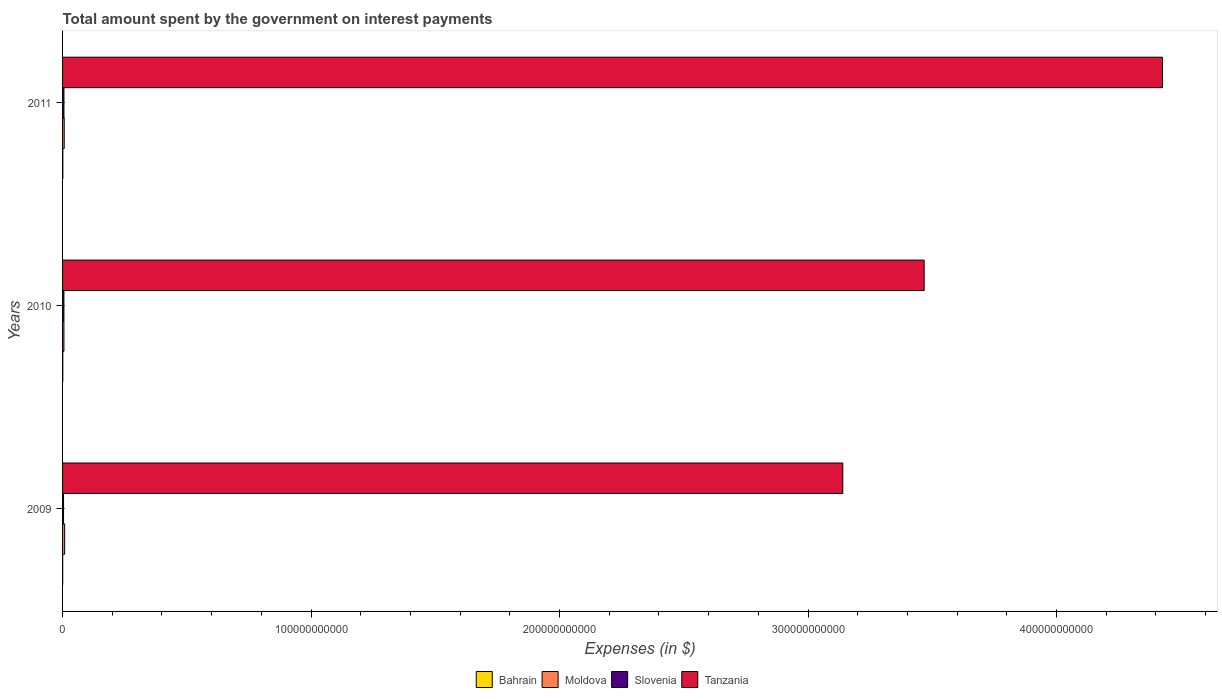How many groups of bars are there?
Your answer should be compact. 3. Are the number of bars on each tick of the Y-axis equal?
Make the answer very short. Yes. How many bars are there on the 3rd tick from the top?
Provide a succinct answer. 4. In how many cases, is the number of bars for a given year not equal to the number of legend labels?
Provide a succinct answer. 0. What is the amount spent on interest payments by the government in Moldova in 2010?
Provide a short and direct response. 5.48e+08. Across all years, what is the maximum amount spent on interest payments by the government in Bahrain?
Provide a short and direct response. 1.15e+08. Across all years, what is the minimum amount spent on interest payments by the government in Bahrain?
Provide a short and direct response. 5.00e+07. In which year was the amount spent on interest payments by the government in Moldova maximum?
Keep it short and to the point. 2009. What is the total amount spent on interest payments by the government in Bahrain in the graph?
Provide a succinct answer. 2.55e+08. What is the difference between the amount spent on interest payments by the government in Tanzania in 2010 and that in 2011?
Offer a terse response. -9.59e+1. What is the difference between the amount spent on interest payments by the government in Moldova in 2010 and the amount spent on interest payments by the government in Slovenia in 2009?
Your response must be concise. 1.52e+08. What is the average amount spent on interest payments by the government in Slovenia per year?
Offer a terse response. 5.00e+08. In the year 2011, what is the difference between the amount spent on interest payments by the government in Tanzania and amount spent on interest payments by the government in Moldova?
Provide a succinct answer. 4.42e+11. What is the ratio of the amount spent on interest payments by the government in Tanzania in 2010 to that in 2011?
Your answer should be compact. 0.78. Is the amount spent on interest payments by the government in Slovenia in 2009 less than that in 2011?
Give a very brief answer. Yes. Is the difference between the amount spent on interest payments by the government in Tanzania in 2010 and 2011 greater than the difference between the amount spent on interest payments by the government in Moldova in 2010 and 2011?
Offer a terse response. No. What is the difference between the highest and the second highest amount spent on interest payments by the government in Bahrain?
Provide a short and direct response. 2.39e+07. What is the difference between the highest and the lowest amount spent on interest payments by the government in Moldova?
Ensure brevity in your answer.  2.87e+08. Is the sum of the amount spent on interest payments by the government in Bahrain in 2009 and 2011 greater than the maximum amount spent on interest payments by the government in Slovenia across all years?
Your response must be concise. No. What does the 4th bar from the top in 2010 represents?
Ensure brevity in your answer.  Bahrain. What does the 4th bar from the bottom in 2009 represents?
Provide a short and direct response. Tanzania. Is it the case that in every year, the sum of the amount spent on interest payments by the government in Tanzania and amount spent on interest payments by the government in Moldova is greater than the amount spent on interest payments by the government in Bahrain?
Your answer should be compact. Yes. Are all the bars in the graph horizontal?
Provide a short and direct response. Yes. How many years are there in the graph?
Provide a succinct answer. 3. What is the difference between two consecutive major ticks on the X-axis?
Provide a short and direct response. 1.00e+11. Does the graph contain any zero values?
Make the answer very short. No. Does the graph contain grids?
Make the answer very short. No. What is the title of the graph?
Your answer should be compact. Total amount spent by the government on interest payments. What is the label or title of the X-axis?
Offer a very short reply. Expenses (in $). What is the label or title of the Y-axis?
Offer a terse response. Years. What is the Expenses (in $) in Bahrain in 2009?
Give a very brief answer. 5.00e+07. What is the Expenses (in $) in Moldova in 2009?
Offer a very short reply. 8.34e+08. What is the Expenses (in $) in Slovenia in 2009?
Your answer should be very brief. 3.96e+08. What is the Expenses (in $) in Tanzania in 2009?
Give a very brief answer. 3.14e+11. What is the Expenses (in $) in Bahrain in 2010?
Your answer should be compact. 9.06e+07. What is the Expenses (in $) of Moldova in 2010?
Make the answer very short. 5.48e+08. What is the Expenses (in $) of Slovenia in 2010?
Make the answer very short. 5.44e+08. What is the Expenses (in $) in Tanzania in 2010?
Your answer should be compact. 3.47e+11. What is the Expenses (in $) of Bahrain in 2011?
Offer a terse response. 1.15e+08. What is the Expenses (in $) in Moldova in 2011?
Your answer should be compact. 6.62e+08. What is the Expenses (in $) in Slovenia in 2011?
Provide a succinct answer. 5.61e+08. What is the Expenses (in $) of Tanzania in 2011?
Offer a terse response. 4.43e+11. Across all years, what is the maximum Expenses (in $) in Bahrain?
Offer a very short reply. 1.15e+08. Across all years, what is the maximum Expenses (in $) of Moldova?
Offer a terse response. 8.34e+08. Across all years, what is the maximum Expenses (in $) of Slovenia?
Your response must be concise. 5.61e+08. Across all years, what is the maximum Expenses (in $) in Tanzania?
Provide a succinct answer. 4.43e+11. Across all years, what is the minimum Expenses (in $) of Bahrain?
Make the answer very short. 5.00e+07. Across all years, what is the minimum Expenses (in $) in Moldova?
Offer a terse response. 5.48e+08. Across all years, what is the minimum Expenses (in $) in Slovenia?
Your answer should be compact. 3.96e+08. Across all years, what is the minimum Expenses (in $) of Tanzania?
Provide a succinct answer. 3.14e+11. What is the total Expenses (in $) of Bahrain in the graph?
Provide a short and direct response. 2.55e+08. What is the total Expenses (in $) in Moldova in the graph?
Provide a succinct answer. 2.04e+09. What is the total Expenses (in $) in Slovenia in the graph?
Provide a succinct answer. 1.50e+09. What is the total Expenses (in $) of Tanzania in the graph?
Provide a succinct answer. 1.10e+12. What is the difference between the Expenses (in $) in Bahrain in 2009 and that in 2010?
Offer a very short reply. -4.05e+07. What is the difference between the Expenses (in $) in Moldova in 2009 and that in 2010?
Ensure brevity in your answer.  2.87e+08. What is the difference between the Expenses (in $) in Slovenia in 2009 and that in 2010?
Keep it short and to the point. -1.49e+08. What is the difference between the Expenses (in $) of Tanzania in 2009 and that in 2010?
Make the answer very short. -3.27e+1. What is the difference between the Expenses (in $) in Bahrain in 2009 and that in 2011?
Your response must be concise. -6.45e+07. What is the difference between the Expenses (in $) in Moldova in 2009 and that in 2011?
Offer a very short reply. 1.72e+08. What is the difference between the Expenses (in $) of Slovenia in 2009 and that in 2011?
Your answer should be compact. -1.65e+08. What is the difference between the Expenses (in $) in Tanzania in 2009 and that in 2011?
Keep it short and to the point. -1.29e+11. What is the difference between the Expenses (in $) in Bahrain in 2010 and that in 2011?
Your answer should be compact. -2.39e+07. What is the difference between the Expenses (in $) of Moldova in 2010 and that in 2011?
Your answer should be compact. -1.15e+08. What is the difference between the Expenses (in $) in Slovenia in 2010 and that in 2011?
Provide a short and direct response. -1.68e+07. What is the difference between the Expenses (in $) of Tanzania in 2010 and that in 2011?
Provide a succinct answer. -9.59e+1. What is the difference between the Expenses (in $) of Bahrain in 2009 and the Expenses (in $) of Moldova in 2010?
Offer a terse response. -4.98e+08. What is the difference between the Expenses (in $) in Bahrain in 2009 and the Expenses (in $) in Slovenia in 2010?
Provide a succinct answer. -4.94e+08. What is the difference between the Expenses (in $) in Bahrain in 2009 and the Expenses (in $) in Tanzania in 2010?
Provide a short and direct response. -3.47e+11. What is the difference between the Expenses (in $) in Moldova in 2009 and the Expenses (in $) in Slovenia in 2010?
Provide a succinct answer. 2.90e+08. What is the difference between the Expenses (in $) of Moldova in 2009 and the Expenses (in $) of Tanzania in 2010?
Keep it short and to the point. -3.46e+11. What is the difference between the Expenses (in $) in Slovenia in 2009 and the Expenses (in $) in Tanzania in 2010?
Offer a very short reply. -3.46e+11. What is the difference between the Expenses (in $) of Bahrain in 2009 and the Expenses (in $) of Moldova in 2011?
Make the answer very short. -6.12e+08. What is the difference between the Expenses (in $) of Bahrain in 2009 and the Expenses (in $) of Slovenia in 2011?
Your answer should be compact. -5.11e+08. What is the difference between the Expenses (in $) of Bahrain in 2009 and the Expenses (in $) of Tanzania in 2011?
Keep it short and to the point. -4.43e+11. What is the difference between the Expenses (in $) in Moldova in 2009 and the Expenses (in $) in Slovenia in 2011?
Your response must be concise. 2.73e+08. What is the difference between the Expenses (in $) of Moldova in 2009 and the Expenses (in $) of Tanzania in 2011?
Your answer should be very brief. -4.42e+11. What is the difference between the Expenses (in $) of Slovenia in 2009 and the Expenses (in $) of Tanzania in 2011?
Your response must be concise. -4.42e+11. What is the difference between the Expenses (in $) in Bahrain in 2010 and the Expenses (in $) in Moldova in 2011?
Your answer should be compact. -5.72e+08. What is the difference between the Expenses (in $) in Bahrain in 2010 and the Expenses (in $) in Slovenia in 2011?
Make the answer very short. -4.70e+08. What is the difference between the Expenses (in $) in Bahrain in 2010 and the Expenses (in $) in Tanzania in 2011?
Provide a short and direct response. -4.43e+11. What is the difference between the Expenses (in $) of Moldova in 2010 and the Expenses (in $) of Slovenia in 2011?
Your answer should be compact. -1.34e+07. What is the difference between the Expenses (in $) of Moldova in 2010 and the Expenses (in $) of Tanzania in 2011?
Make the answer very short. -4.42e+11. What is the difference between the Expenses (in $) of Slovenia in 2010 and the Expenses (in $) of Tanzania in 2011?
Offer a very short reply. -4.42e+11. What is the average Expenses (in $) in Bahrain per year?
Your response must be concise. 8.50e+07. What is the average Expenses (in $) of Moldova per year?
Provide a succinct answer. 6.81e+08. What is the average Expenses (in $) of Slovenia per year?
Provide a succinct answer. 5.00e+08. What is the average Expenses (in $) in Tanzania per year?
Give a very brief answer. 3.68e+11. In the year 2009, what is the difference between the Expenses (in $) in Bahrain and Expenses (in $) in Moldova?
Your answer should be very brief. -7.84e+08. In the year 2009, what is the difference between the Expenses (in $) in Bahrain and Expenses (in $) in Slovenia?
Ensure brevity in your answer.  -3.46e+08. In the year 2009, what is the difference between the Expenses (in $) of Bahrain and Expenses (in $) of Tanzania?
Offer a terse response. -3.14e+11. In the year 2009, what is the difference between the Expenses (in $) in Moldova and Expenses (in $) in Slovenia?
Offer a terse response. 4.38e+08. In the year 2009, what is the difference between the Expenses (in $) in Moldova and Expenses (in $) in Tanzania?
Your answer should be very brief. -3.13e+11. In the year 2009, what is the difference between the Expenses (in $) of Slovenia and Expenses (in $) of Tanzania?
Your answer should be compact. -3.14e+11. In the year 2010, what is the difference between the Expenses (in $) in Bahrain and Expenses (in $) in Moldova?
Offer a terse response. -4.57e+08. In the year 2010, what is the difference between the Expenses (in $) in Bahrain and Expenses (in $) in Slovenia?
Your answer should be compact. -4.54e+08. In the year 2010, what is the difference between the Expenses (in $) of Bahrain and Expenses (in $) of Tanzania?
Provide a short and direct response. -3.47e+11. In the year 2010, what is the difference between the Expenses (in $) of Moldova and Expenses (in $) of Slovenia?
Offer a terse response. 3.36e+06. In the year 2010, what is the difference between the Expenses (in $) of Moldova and Expenses (in $) of Tanzania?
Offer a very short reply. -3.46e+11. In the year 2010, what is the difference between the Expenses (in $) in Slovenia and Expenses (in $) in Tanzania?
Keep it short and to the point. -3.46e+11. In the year 2011, what is the difference between the Expenses (in $) in Bahrain and Expenses (in $) in Moldova?
Your answer should be compact. -5.48e+08. In the year 2011, what is the difference between the Expenses (in $) in Bahrain and Expenses (in $) in Slovenia?
Give a very brief answer. -4.47e+08. In the year 2011, what is the difference between the Expenses (in $) in Bahrain and Expenses (in $) in Tanzania?
Make the answer very short. -4.43e+11. In the year 2011, what is the difference between the Expenses (in $) of Moldova and Expenses (in $) of Slovenia?
Offer a very short reply. 1.01e+08. In the year 2011, what is the difference between the Expenses (in $) of Moldova and Expenses (in $) of Tanzania?
Offer a terse response. -4.42e+11. In the year 2011, what is the difference between the Expenses (in $) in Slovenia and Expenses (in $) in Tanzania?
Make the answer very short. -4.42e+11. What is the ratio of the Expenses (in $) of Bahrain in 2009 to that in 2010?
Ensure brevity in your answer.  0.55. What is the ratio of the Expenses (in $) in Moldova in 2009 to that in 2010?
Your answer should be compact. 1.52. What is the ratio of the Expenses (in $) of Slovenia in 2009 to that in 2010?
Your response must be concise. 0.73. What is the ratio of the Expenses (in $) of Tanzania in 2009 to that in 2010?
Offer a very short reply. 0.91. What is the ratio of the Expenses (in $) in Bahrain in 2009 to that in 2011?
Your response must be concise. 0.44. What is the ratio of the Expenses (in $) of Moldova in 2009 to that in 2011?
Your answer should be very brief. 1.26. What is the ratio of the Expenses (in $) in Slovenia in 2009 to that in 2011?
Make the answer very short. 0.71. What is the ratio of the Expenses (in $) of Tanzania in 2009 to that in 2011?
Offer a terse response. 0.71. What is the ratio of the Expenses (in $) of Bahrain in 2010 to that in 2011?
Ensure brevity in your answer.  0.79. What is the ratio of the Expenses (in $) of Moldova in 2010 to that in 2011?
Offer a very short reply. 0.83. What is the ratio of the Expenses (in $) in Slovenia in 2010 to that in 2011?
Your answer should be very brief. 0.97. What is the ratio of the Expenses (in $) of Tanzania in 2010 to that in 2011?
Provide a succinct answer. 0.78. What is the difference between the highest and the second highest Expenses (in $) in Bahrain?
Your answer should be compact. 2.39e+07. What is the difference between the highest and the second highest Expenses (in $) of Moldova?
Give a very brief answer. 1.72e+08. What is the difference between the highest and the second highest Expenses (in $) in Slovenia?
Offer a very short reply. 1.68e+07. What is the difference between the highest and the second highest Expenses (in $) in Tanzania?
Ensure brevity in your answer.  9.59e+1. What is the difference between the highest and the lowest Expenses (in $) in Bahrain?
Give a very brief answer. 6.45e+07. What is the difference between the highest and the lowest Expenses (in $) of Moldova?
Your answer should be very brief. 2.87e+08. What is the difference between the highest and the lowest Expenses (in $) in Slovenia?
Provide a succinct answer. 1.65e+08. What is the difference between the highest and the lowest Expenses (in $) of Tanzania?
Ensure brevity in your answer.  1.29e+11. 